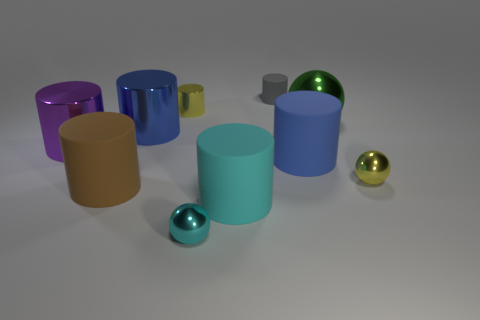Subtract all blue cylinders. How many cylinders are left? 5 Subtract all purple cylinders. How many cylinders are left? 6 Subtract all balls. How many objects are left? 7 Subtract all red cylinders. Subtract all purple cubes. How many cylinders are left? 7 Subtract all gray blocks. How many cyan cylinders are left? 1 Subtract all big green objects. Subtract all yellow shiny blocks. How many objects are left? 9 Add 3 metal cylinders. How many metal cylinders are left? 6 Add 1 red matte blocks. How many red matte blocks exist? 1 Subtract 0 green cubes. How many objects are left? 10 Subtract 1 balls. How many balls are left? 2 